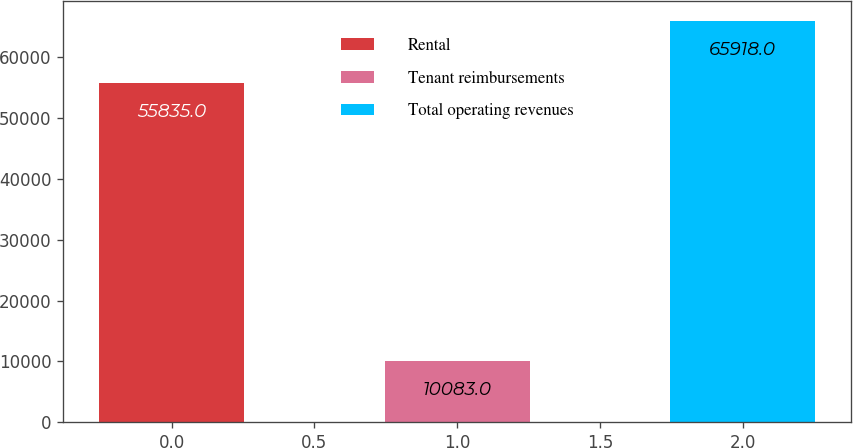Convert chart. <chart><loc_0><loc_0><loc_500><loc_500><bar_chart><fcel>Rental<fcel>Tenant reimbursements<fcel>Total operating revenues<nl><fcel>55835<fcel>10083<fcel>65918<nl></chart> 